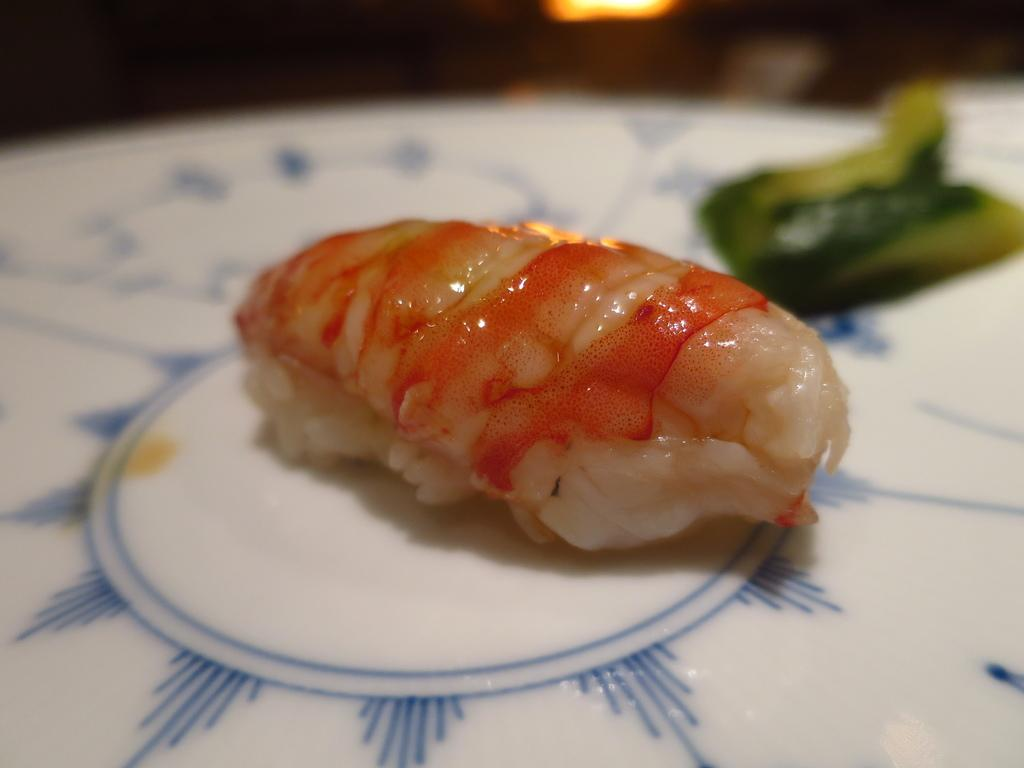What is on the plate in the image? There is food on a white color plate in the image. Can you describe the colors of the food on the plate? The food has orange, cream, white, and green colors. What type of glove is being used to eat the food in the image? There is no glove present in the image, and the food is not being eaten. 